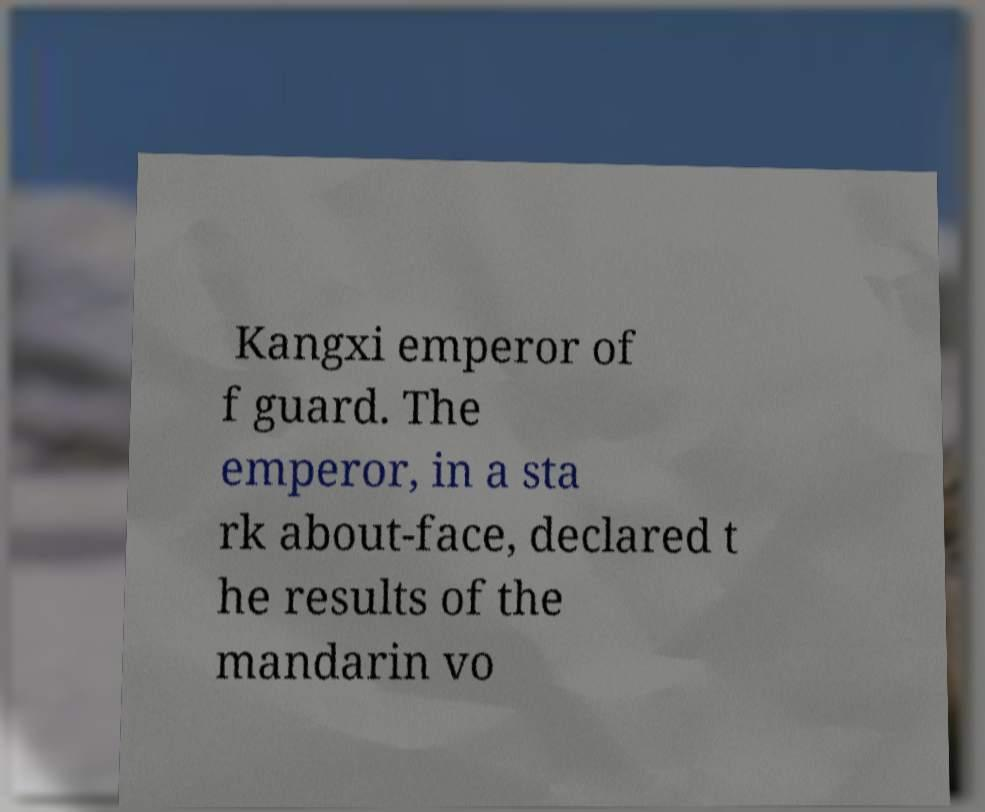Can you accurately transcribe the text from the provided image for me? Kangxi emperor of f guard. The emperor, in a sta rk about-face, declared t he results of the mandarin vo 